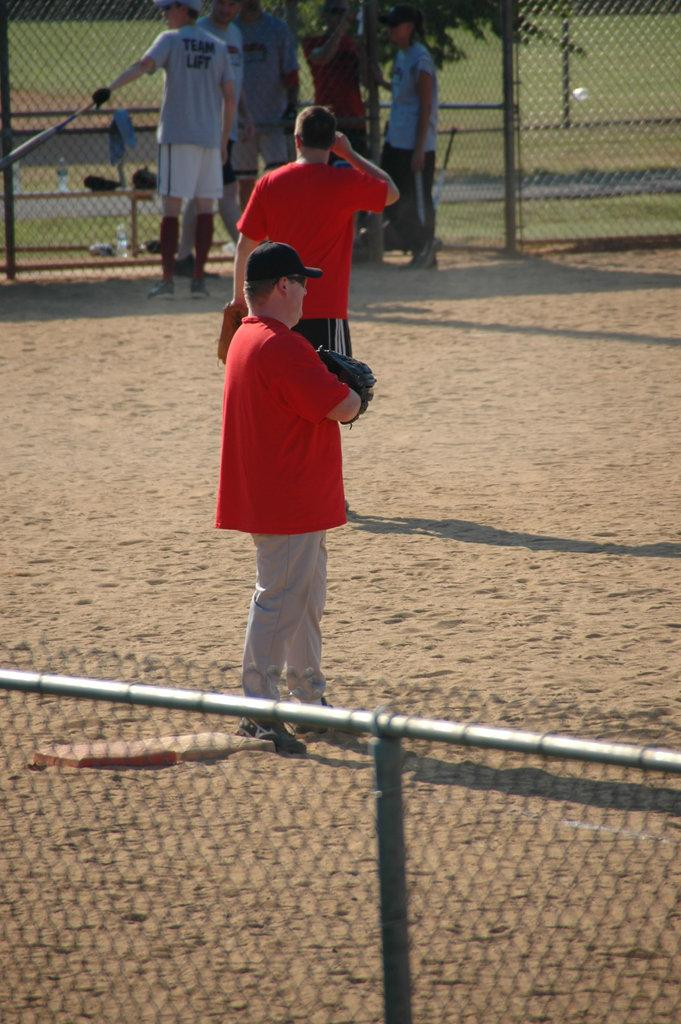What is the primary subject of the image? The primary subject of the image is the persons on the ground. What type of vegetation is present in the image? There is a tree in the image. What type of barrier is visible in the image? There is fencing in the image. What can be seen in the background of the image? There is grass visible in the background of the image. How many sisters are present in the image? There is no mention of sisters in the image, so we cannot determine their presence or number. 